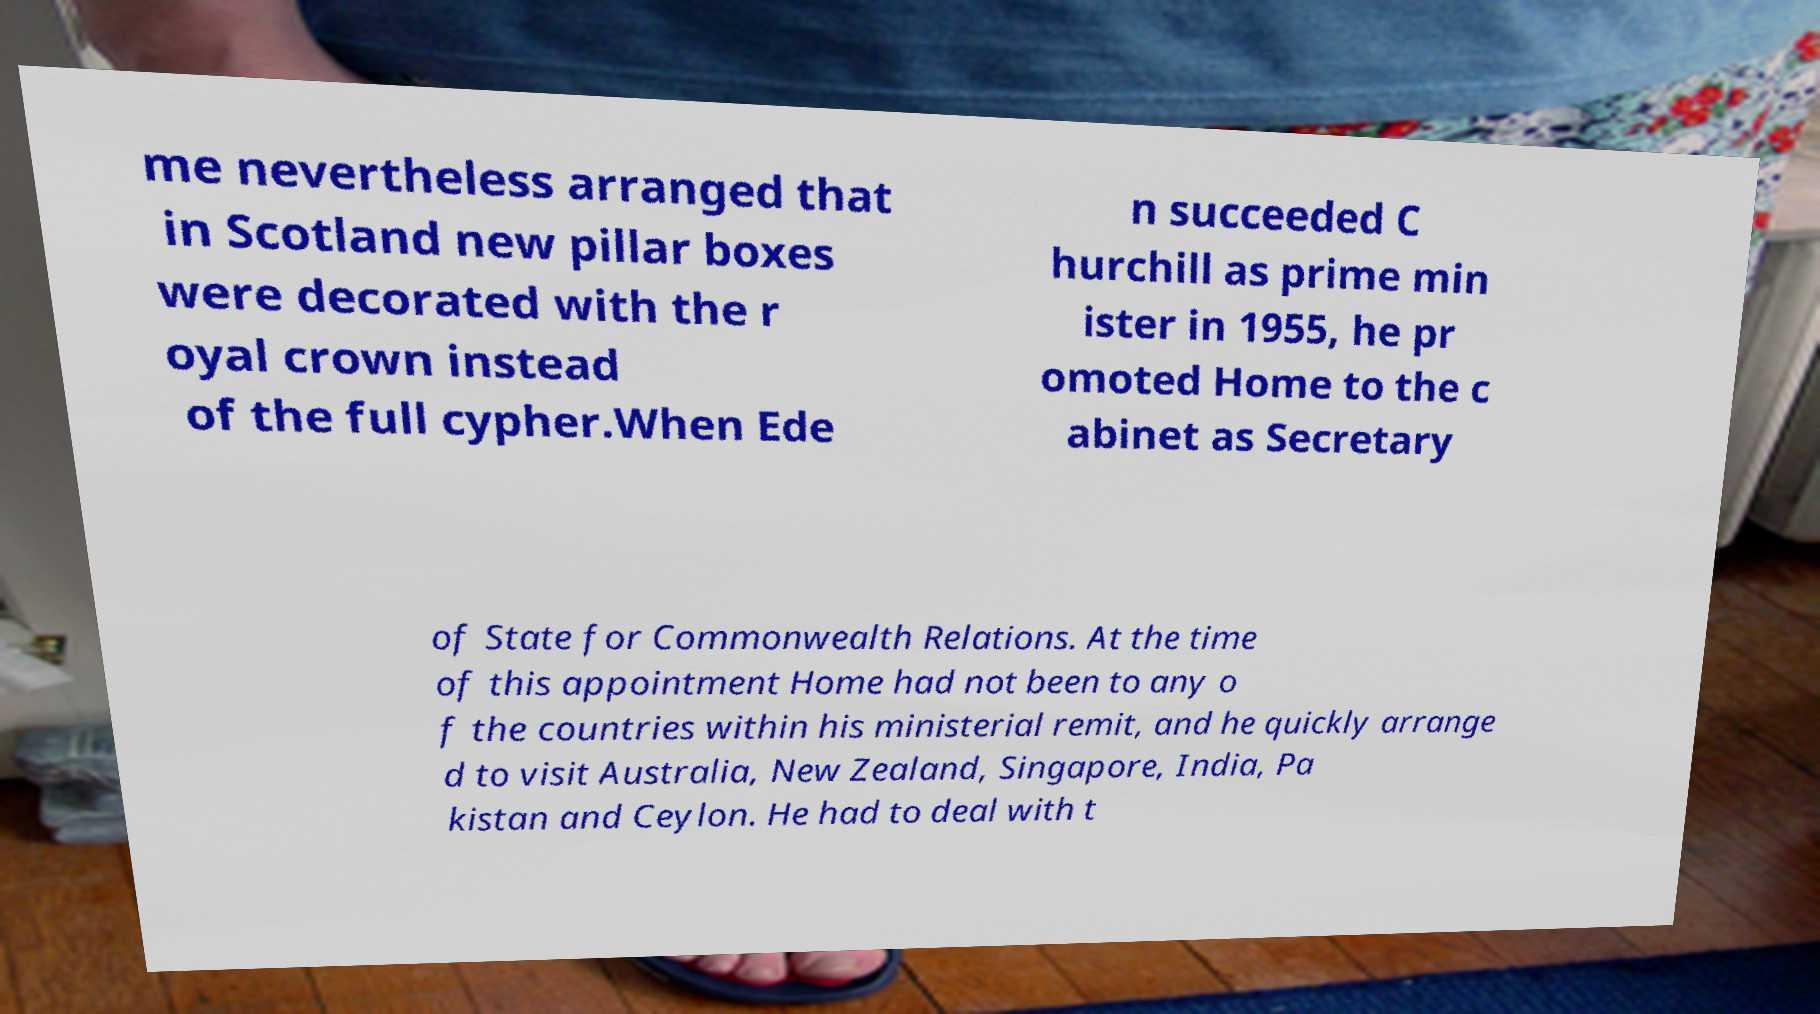There's text embedded in this image that I need extracted. Can you transcribe it verbatim? me nevertheless arranged that in Scotland new pillar boxes were decorated with the r oyal crown instead of the full cypher.When Ede n succeeded C hurchill as prime min ister in 1955, he pr omoted Home to the c abinet as Secretary of State for Commonwealth Relations. At the time of this appointment Home had not been to any o f the countries within his ministerial remit, and he quickly arrange d to visit Australia, New Zealand, Singapore, India, Pa kistan and Ceylon. He had to deal with t 